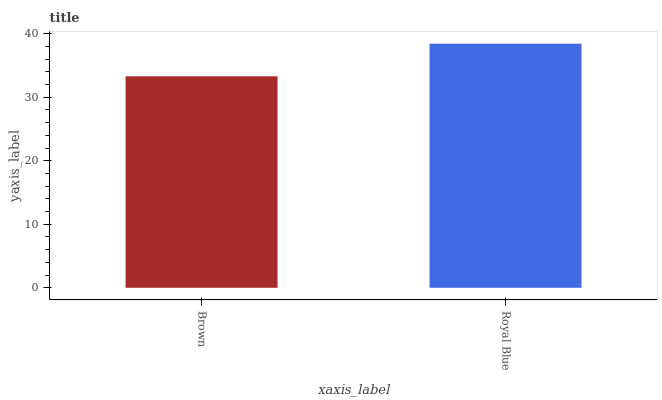Is Brown the minimum?
Answer yes or no. Yes. Is Royal Blue the maximum?
Answer yes or no. Yes. Is Royal Blue the minimum?
Answer yes or no. No. Is Royal Blue greater than Brown?
Answer yes or no. Yes. Is Brown less than Royal Blue?
Answer yes or no. Yes. Is Brown greater than Royal Blue?
Answer yes or no. No. Is Royal Blue less than Brown?
Answer yes or no. No. Is Royal Blue the high median?
Answer yes or no. Yes. Is Brown the low median?
Answer yes or no. Yes. Is Brown the high median?
Answer yes or no. No. Is Royal Blue the low median?
Answer yes or no. No. 